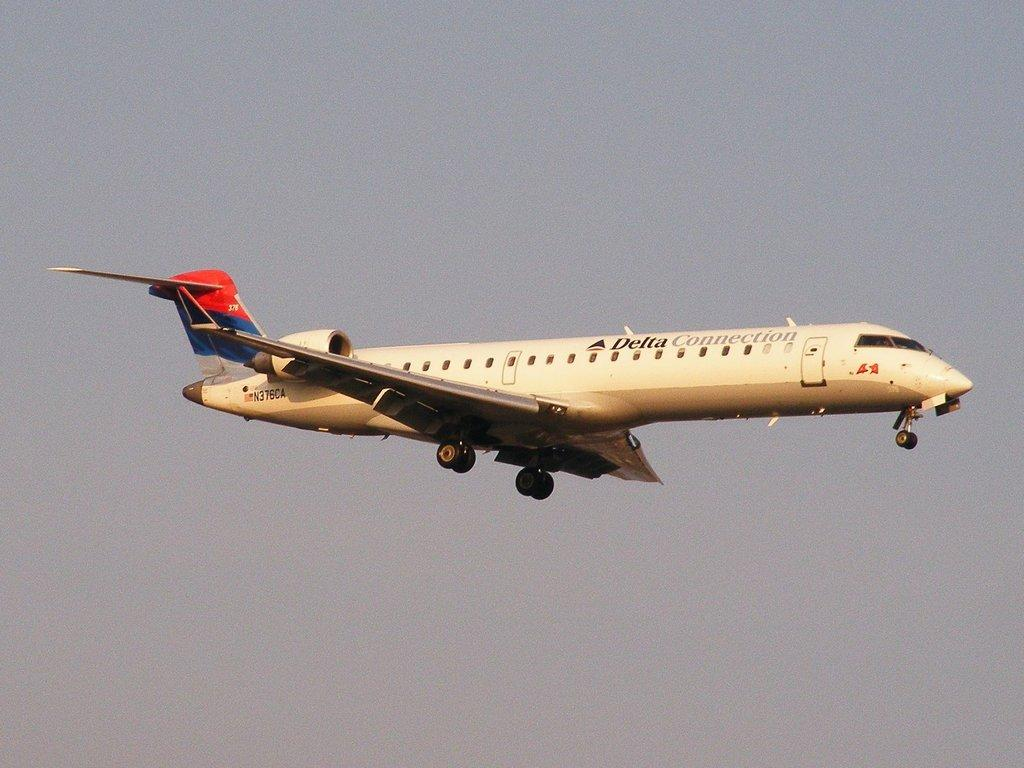<image>
Relay a brief, clear account of the picture shown. A delta plane is flying in the air. 